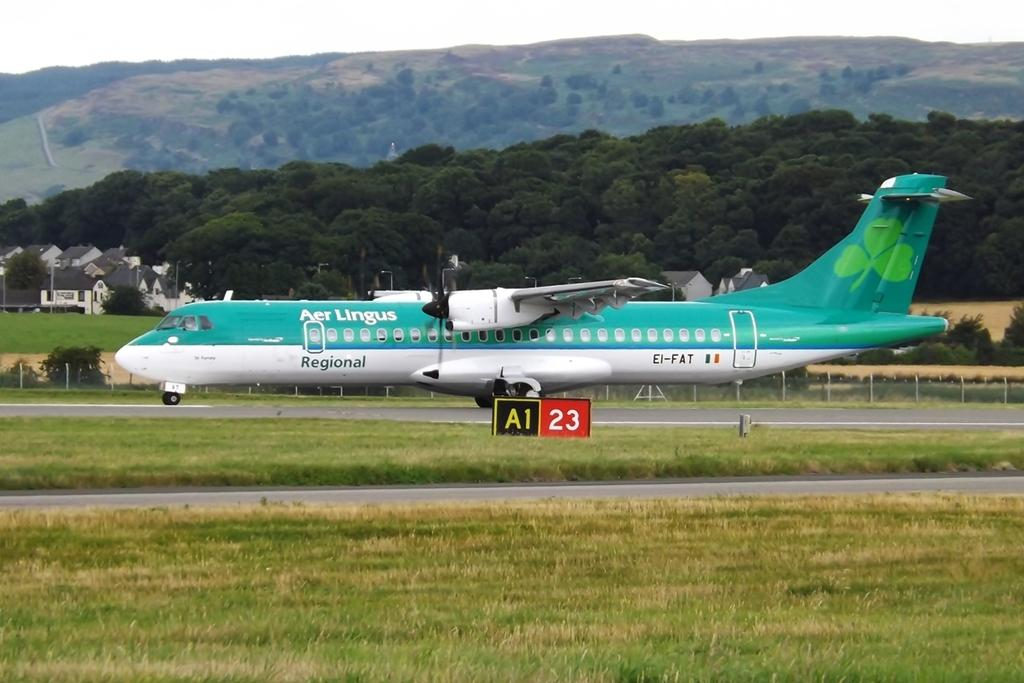Provide a one-sentence caption for the provided image. An Aer Lingus airplane is on runway A1 23. 